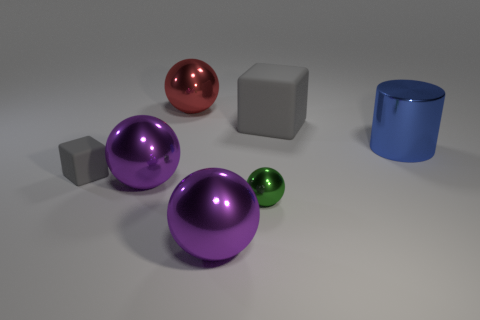There is a thing that is the same color as the large rubber block; what is its material?
Keep it short and to the point. Rubber. What material is the other gray thing that is the same shape as the large gray thing?
Keep it short and to the point. Rubber. Does the block in front of the large matte object have the same material as the big cylinder?
Your answer should be very brief. No. Are there an equal number of large blue cylinders that are left of the metal cylinder and tiny rubber objects on the left side of the big red thing?
Make the answer very short. No. What size is the matte object behind the small rubber cube?
Ensure brevity in your answer.  Large. Is there a green thing made of the same material as the big red ball?
Provide a succinct answer. Yes. Do the tiny cube to the left of the green thing and the large rubber cube have the same color?
Your answer should be compact. Yes. Are there the same number of tiny blocks in front of the green metal thing and gray rubber objects?
Your answer should be compact. No. Are there any small rubber blocks of the same color as the big matte cube?
Provide a succinct answer. Yes. Is the size of the blue cylinder the same as the green metal sphere?
Your answer should be very brief. No. 